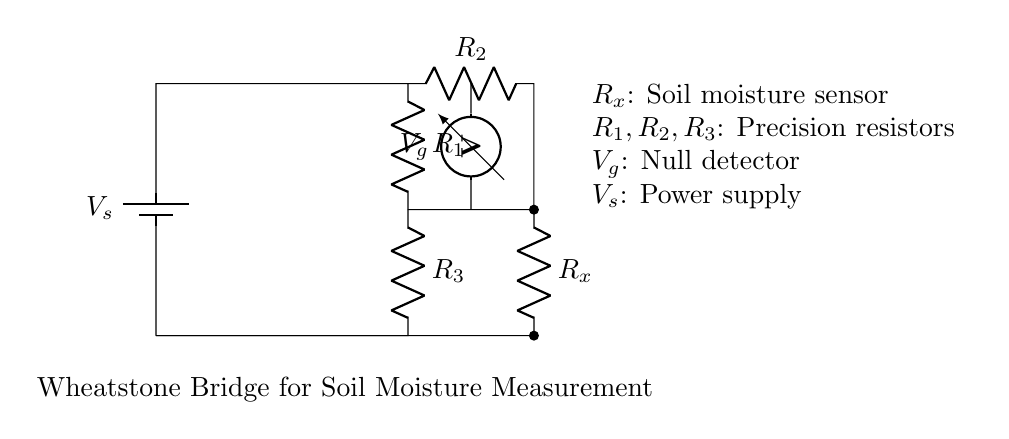What is the function of \( V_g \)? \( V_g \) is a null detector used to measure the voltage difference in the bridge, indicating the balance point for soil moisture detection.
Answer: Null detector What type of circuit is represented? The circuit is a Wheatstone bridge, which is specifically designed for measuring resistances, particularly in this case for soil moisture.
Answer: Wheatstone bridge What is the role of \( R_x \)? \( R_x \) represents the soil moisture sensor resistance, which changes based on the moisture level in the soil, affecting the balance of the bridge.
Answer: Soil moisture sensor How many resistors are present in this circuit? The circuit has three precision resistors: \( R_1 \), \( R_2 \), and \( R_3 \), which are essential for creating the voltage divider in the bridge configuration.
Answer: Three What is the voltage source in this circuit? The voltage source is labeled \( V_s \), which provides the necessary voltage for the operation of the Wheatstone bridge circuit.
Answer: Voltage source What happens when the bridge is balanced? When the bridge is balanced, the voltage \( V_g \) is zero, indicating that the soil moisture level is at a certain calibrated point, meaning no current flows through the null detector.
Answer: Voltage is zero What is the purpose of \( R_1, R_2, \) and \( R_3 \)? These resistors are used for precision measurements and help in adjusting the voltage levels in the circuit to achieve balance for accurate soil moisture readings.
Answer: Precision resistors 